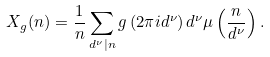Convert formula to latex. <formula><loc_0><loc_0><loc_500><loc_500>X _ { g } ( n ) = \frac { 1 } { n } \sum _ { d ^ { \nu } | n } g \left ( 2 \pi i d ^ { \nu } \right ) d ^ { \nu } \mu \left ( \frac { n } { d ^ { \nu } } \right ) .</formula> 